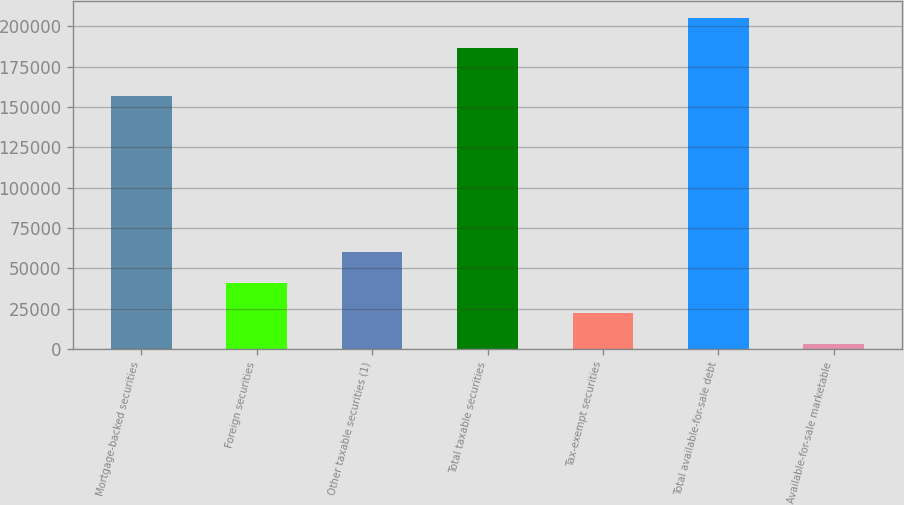Convert chart. <chart><loc_0><loc_0><loc_500><loc_500><bar_chart><fcel>Mortgage-backed securities<fcel>Foreign securities<fcel>Other taxable securities (1)<fcel>Total taxable securities<fcel>Tax-exempt securities<fcel>Total available-for-sale debt<fcel>Available-for-sale marketable<nl><fcel>156893<fcel>41118.8<fcel>60079.7<fcel>186283<fcel>22157.9<fcel>205244<fcel>3197<nl></chart> 